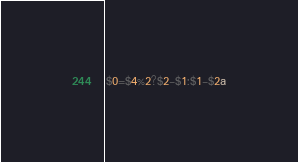<code> <loc_0><loc_0><loc_500><loc_500><_Awk_>$0=$4%2?$2-$1:$1-$2a</code> 